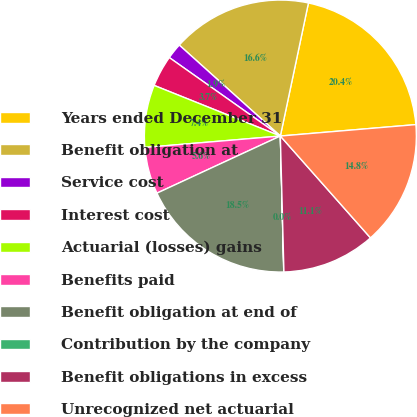Convert chart. <chart><loc_0><loc_0><loc_500><loc_500><pie_chart><fcel>Years ended December 31<fcel>Benefit obligation at<fcel>Service cost<fcel>Interest cost<fcel>Actuarial (losses) gains<fcel>Benefits paid<fcel>Benefit obligation at end of<fcel>Contribution by the company<fcel>Benefit obligations in excess<fcel>Unrecognized net actuarial<nl><fcel>20.35%<fcel>16.65%<fcel>1.87%<fcel>3.72%<fcel>7.41%<fcel>5.56%<fcel>18.5%<fcel>0.02%<fcel>11.11%<fcel>14.81%<nl></chart> 